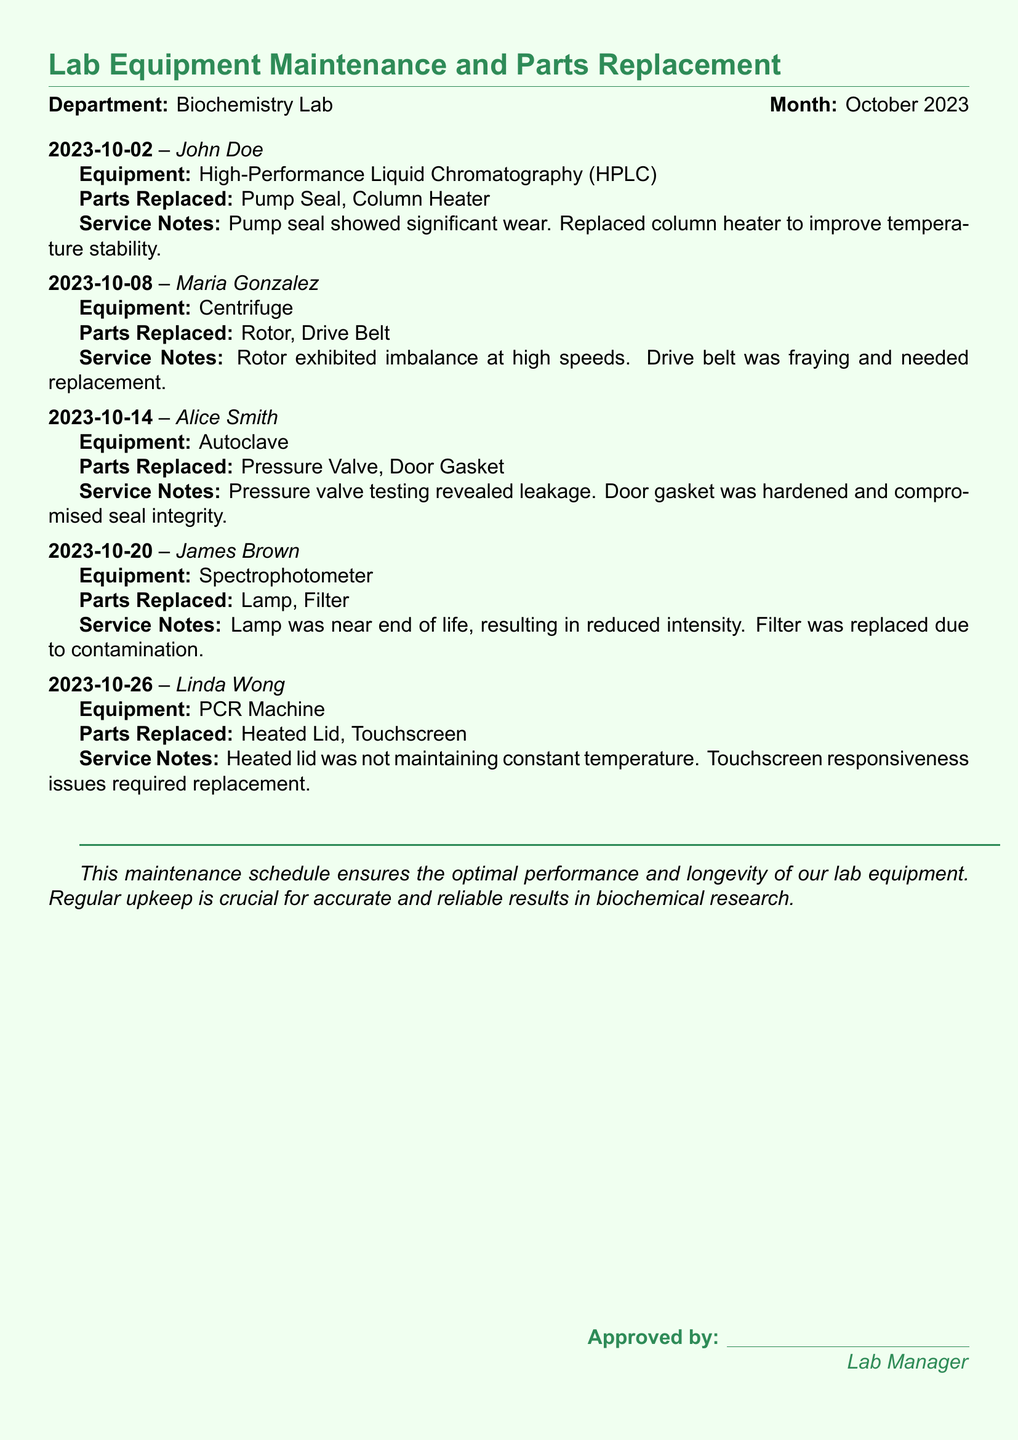What date was the HPLC maintenance performed? The HPLC maintenance was conducted on October 2, 2023.
Answer: October 2, 2023 Who replaced the rotor in the centrifuge? The rotor was replaced by Maria Gonzalez.
Answer: Maria Gonzalez What parts were replaced in the autoclave? The autoclave had its pressure valve and door gasket replaced.
Answer: Pressure Valve, Door Gasket What issue was identified with the PCR machine? The PCR machine had issues with the heated lid maintaining temperature and touchscreen responsiveness.
Answer: Heated Lid, Touchscreen Which technician worked on the spectrophotometer? The technician assigned to the spectrophotometer was James Brown.
Answer: James Brown How many pieces of equipment were serviced in October? The document lists a total of five pieces of equipment that were serviced in October 2023.
Answer: Five What was replaced due to contamination in the spectrophotometer? The filter was replaced because of contamination.
Answer: Filter On what date was the maintenance on the centrifuge completed? The maintenance on the centrifuge was completed on October 8, 2023.
Answer: October 8, 2023 What are the main reasons for conducting regular maintenance? Regular maintenance is crucial for optimal performance and reliability in biochemical research results.
Answer: Optimal performance, reliability 